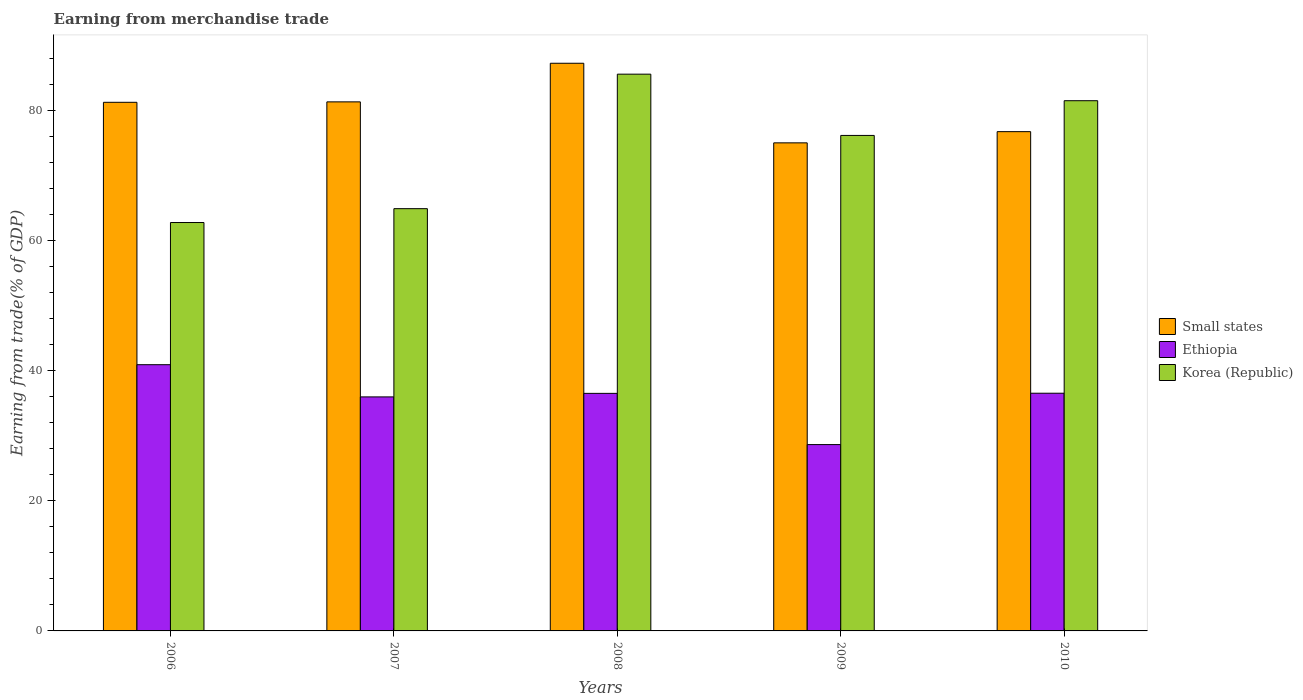How many different coloured bars are there?
Offer a terse response. 3. How many groups of bars are there?
Offer a terse response. 5. How many bars are there on the 3rd tick from the left?
Make the answer very short. 3. How many bars are there on the 5th tick from the right?
Your response must be concise. 3. What is the label of the 2nd group of bars from the left?
Make the answer very short. 2007. What is the earnings from trade in Korea (Republic) in 2008?
Ensure brevity in your answer.  85.54. Across all years, what is the maximum earnings from trade in Small states?
Your response must be concise. 87.21. Across all years, what is the minimum earnings from trade in Korea (Republic)?
Your answer should be compact. 62.74. In which year was the earnings from trade in Korea (Republic) minimum?
Keep it short and to the point. 2006. What is the total earnings from trade in Small states in the graph?
Keep it short and to the point. 401.41. What is the difference between the earnings from trade in Small states in 2006 and that in 2008?
Your response must be concise. -6. What is the difference between the earnings from trade in Korea (Republic) in 2007 and the earnings from trade in Small states in 2006?
Your answer should be compact. -16.34. What is the average earnings from trade in Ethiopia per year?
Provide a short and direct response. 35.7. In the year 2008, what is the difference between the earnings from trade in Ethiopia and earnings from trade in Small states?
Give a very brief answer. -50.72. What is the ratio of the earnings from trade in Ethiopia in 2007 to that in 2010?
Your response must be concise. 0.98. What is the difference between the highest and the second highest earnings from trade in Korea (Republic)?
Your response must be concise. 4.08. What is the difference between the highest and the lowest earnings from trade in Small states?
Give a very brief answer. 12.23. Is the sum of the earnings from trade in Small states in 2006 and 2007 greater than the maximum earnings from trade in Korea (Republic) across all years?
Offer a terse response. Yes. What does the 1st bar from the left in 2009 represents?
Offer a very short reply. Small states. What does the 2nd bar from the right in 2007 represents?
Keep it short and to the point. Ethiopia. Is it the case that in every year, the sum of the earnings from trade in Korea (Republic) and earnings from trade in Ethiopia is greater than the earnings from trade in Small states?
Your answer should be very brief. Yes. How many years are there in the graph?
Your answer should be very brief. 5. What is the difference between two consecutive major ticks on the Y-axis?
Make the answer very short. 20. Are the values on the major ticks of Y-axis written in scientific E-notation?
Provide a succinct answer. No. Does the graph contain any zero values?
Offer a terse response. No. Does the graph contain grids?
Make the answer very short. No. Where does the legend appear in the graph?
Offer a very short reply. Center right. What is the title of the graph?
Provide a succinct answer. Earning from merchandise trade. Does "Montenegro" appear as one of the legend labels in the graph?
Your answer should be very brief. No. What is the label or title of the X-axis?
Ensure brevity in your answer.  Years. What is the label or title of the Y-axis?
Offer a very short reply. Earning from trade(% of GDP). What is the Earning from trade(% of GDP) of Small states in 2006?
Offer a very short reply. 81.22. What is the Earning from trade(% of GDP) in Ethiopia in 2006?
Provide a succinct answer. 40.9. What is the Earning from trade(% of GDP) in Korea (Republic) in 2006?
Make the answer very short. 62.74. What is the Earning from trade(% of GDP) of Small states in 2007?
Provide a succinct answer. 81.28. What is the Earning from trade(% of GDP) in Ethiopia in 2007?
Offer a very short reply. 35.95. What is the Earning from trade(% of GDP) of Korea (Republic) in 2007?
Offer a very short reply. 64.87. What is the Earning from trade(% of GDP) of Small states in 2008?
Your response must be concise. 87.21. What is the Earning from trade(% of GDP) in Ethiopia in 2008?
Offer a very short reply. 36.5. What is the Earning from trade(% of GDP) of Korea (Republic) in 2008?
Keep it short and to the point. 85.54. What is the Earning from trade(% of GDP) in Small states in 2009?
Make the answer very short. 74.99. What is the Earning from trade(% of GDP) of Ethiopia in 2009?
Give a very brief answer. 28.63. What is the Earning from trade(% of GDP) in Korea (Republic) in 2009?
Give a very brief answer. 76.13. What is the Earning from trade(% of GDP) of Small states in 2010?
Offer a terse response. 76.71. What is the Earning from trade(% of GDP) in Ethiopia in 2010?
Offer a terse response. 36.52. What is the Earning from trade(% of GDP) of Korea (Republic) in 2010?
Make the answer very short. 81.46. Across all years, what is the maximum Earning from trade(% of GDP) in Small states?
Provide a short and direct response. 87.21. Across all years, what is the maximum Earning from trade(% of GDP) of Ethiopia?
Provide a short and direct response. 40.9. Across all years, what is the maximum Earning from trade(% of GDP) in Korea (Republic)?
Your answer should be very brief. 85.54. Across all years, what is the minimum Earning from trade(% of GDP) in Small states?
Your answer should be very brief. 74.99. Across all years, what is the minimum Earning from trade(% of GDP) of Ethiopia?
Offer a very short reply. 28.63. Across all years, what is the minimum Earning from trade(% of GDP) in Korea (Republic)?
Your answer should be compact. 62.74. What is the total Earning from trade(% of GDP) in Small states in the graph?
Offer a very short reply. 401.41. What is the total Earning from trade(% of GDP) in Ethiopia in the graph?
Your answer should be very brief. 178.5. What is the total Earning from trade(% of GDP) of Korea (Republic) in the graph?
Your response must be concise. 370.75. What is the difference between the Earning from trade(% of GDP) in Small states in 2006 and that in 2007?
Ensure brevity in your answer.  -0.07. What is the difference between the Earning from trade(% of GDP) in Ethiopia in 2006 and that in 2007?
Keep it short and to the point. 4.95. What is the difference between the Earning from trade(% of GDP) in Korea (Republic) in 2006 and that in 2007?
Offer a terse response. -2.13. What is the difference between the Earning from trade(% of GDP) of Small states in 2006 and that in 2008?
Your answer should be very brief. -6. What is the difference between the Earning from trade(% of GDP) in Ethiopia in 2006 and that in 2008?
Ensure brevity in your answer.  4.41. What is the difference between the Earning from trade(% of GDP) in Korea (Republic) in 2006 and that in 2008?
Your answer should be very brief. -22.79. What is the difference between the Earning from trade(% of GDP) in Small states in 2006 and that in 2009?
Ensure brevity in your answer.  6.23. What is the difference between the Earning from trade(% of GDP) of Ethiopia in 2006 and that in 2009?
Make the answer very short. 12.27. What is the difference between the Earning from trade(% of GDP) in Korea (Republic) in 2006 and that in 2009?
Your answer should be very brief. -13.38. What is the difference between the Earning from trade(% of GDP) of Small states in 2006 and that in 2010?
Ensure brevity in your answer.  4.51. What is the difference between the Earning from trade(% of GDP) in Ethiopia in 2006 and that in 2010?
Offer a very short reply. 4.38. What is the difference between the Earning from trade(% of GDP) in Korea (Republic) in 2006 and that in 2010?
Provide a short and direct response. -18.72. What is the difference between the Earning from trade(% of GDP) in Small states in 2007 and that in 2008?
Provide a short and direct response. -5.93. What is the difference between the Earning from trade(% of GDP) of Ethiopia in 2007 and that in 2008?
Provide a short and direct response. -0.54. What is the difference between the Earning from trade(% of GDP) of Korea (Republic) in 2007 and that in 2008?
Offer a very short reply. -20.66. What is the difference between the Earning from trade(% of GDP) of Small states in 2007 and that in 2009?
Provide a succinct answer. 6.3. What is the difference between the Earning from trade(% of GDP) of Ethiopia in 2007 and that in 2009?
Provide a short and direct response. 7.33. What is the difference between the Earning from trade(% of GDP) of Korea (Republic) in 2007 and that in 2009?
Your answer should be very brief. -11.25. What is the difference between the Earning from trade(% of GDP) of Small states in 2007 and that in 2010?
Make the answer very short. 4.58. What is the difference between the Earning from trade(% of GDP) of Ethiopia in 2007 and that in 2010?
Make the answer very short. -0.56. What is the difference between the Earning from trade(% of GDP) in Korea (Republic) in 2007 and that in 2010?
Offer a very short reply. -16.59. What is the difference between the Earning from trade(% of GDP) in Small states in 2008 and that in 2009?
Your answer should be compact. 12.23. What is the difference between the Earning from trade(% of GDP) in Ethiopia in 2008 and that in 2009?
Give a very brief answer. 7.87. What is the difference between the Earning from trade(% of GDP) in Korea (Republic) in 2008 and that in 2009?
Your answer should be very brief. 9.41. What is the difference between the Earning from trade(% of GDP) in Small states in 2008 and that in 2010?
Provide a short and direct response. 10.51. What is the difference between the Earning from trade(% of GDP) of Ethiopia in 2008 and that in 2010?
Keep it short and to the point. -0.02. What is the difference between the Earning from trade(% of GDP) in Korea (Republic) in 2008 and that in 2010?
Provide a short and direct response. 4.08. What is the difference between the Earning from trade(% of GDP) of Small states in 2009 and that in 2010?
Provide a succinct answer. -1.72. What is the difference between the Earning from trade(% of GDP) in Ethiopia in 2009 and that in 2010?
Offer a very short reply. -7.89. What is the difference between the Earning from trade(% of GDP) in Korea (Republic) in 2009 and that in 2010?
Offer a terse response. -5.33. What is the difference between the Earning from trade(% of GDP) in Small states in 2006 and the Earning from trade(% of GDP) in Ethiopia in 2007?
Ensure brevity in your answer.  45.26. What is the difference between the Earning from trade(% of GDP) of Small states in 2006 and the Earning from trade(% of GDP) of Korea (Republic) in 2007?
Offer a terse response. 16.34. What is the difference between the Earning from trade(% of GDP) in Ethiopia in 2006 and the Earning from trade(% of GDP) in Korea (Republic) in 2007?
Your answer should be very brief. -23.97. What is the difference between the Earning from trade(% of GDP) in Small states in 2006 and the Earning from trade(% of GDP) in Ethiopia in 2008?
Your answer should be compact. 44.72. What is the difference between the Earning from trade(% of GDP) in Small states in 2006 and the Earning from trade(% of GDP) in Korea (Republic) in 2008?
Offer a very short reply. -4.32. What is the difference between the Earning from trade(% of GDP) of Ethiopia in 2006 and the Earning from trade(% of GDP) of Korea (Republic) in 2008?
Give a very brief answer. -44.64. What is the difference between the Earning from trade(% of GDP) of Small states in 2006 and the Earning from trade(% of GDP) of Ethiopia in 2009?
Provide a succinct answer. 52.59. What is the difference between the Earning from trade(% of GDP) of Small states in 2006 and the Earning from trade(% of GDP) of Korea (Republic) in 2009?
Offer a terse response. 5.09. What is the difference between the Earning from trade(% of GDP) in Ethiopia in 2006 and the Earning from trade(% of GDP) in Korea (Republic) in 2009?
Make the answer very short. -35.22. What is the difference between the Earning from trade(% of GDP) in Small states in 2006 and the Earning from trade(% of GDP) in Ethiopia in 2010?
Provide a succinct answer. 44.7. What is the difference between the Earning from trade(% of GDP) in Small states in 2006 and the Earning from trade(% of GDP) in Korea (Republic) in 2010?
Provide a short and direct response. -0.25. What is the difference between the Earning from trade(% of GDP) of Ethiopia in 2006 and the Earning from trade(% of GDP) of Korea (Republic) in 2010?
Make the answer very short. -40.56. What is the difference between the Earning from trade(% of GDP) in Small states in 2007 and the Earning from trade(% of GDP) in Ethiopia in 2008?
Your answer should be very brief. 44.79. What is the difference between the Earning from trade(% of GDP) of Small states in 2007 and the Earning from trade(% of GDP) of Korea (Republic) in 2008?
Offer a very short reply. -4.26. What is the difference between the Earning from trade(% of GDP) of Ethiopia in 2007 and the Earning from trade(% of GDP) of Korea (Republic) in 2008?
Provide a short and direct response. -49.58. What is the difference between the Earning from trade(% of GDP) of Small states in 2007 and the Earning from trade(% of GDP) of Ethiopia in 2009?
Provide a succinct answer. 52.65. What is the difference between the Earning from trade(% of GDP) of Small states in 2007 and the Earning from trade(% of GDP) of Korea (Republic) in 2009?
Provide a short and direct response. 5.16. What is the difference between the Earning from trade(% of GDP) in Ethiopia in 2007 and the Earning from trade(% of GDP) in Korea (Republic) in 2009?
Your answer should be compact. -40.17. What is the difference between the Earning from trade(% of GDP) of Small states in 2007 and the Earning from trade(% of GDP) of Ethiopia in 2010?
Offer a very short reply. 44.76. What is the difference between the Earning from trade(% of GDP) in Small states in 2007 and the Earning from trade(% of GDP) in Korea (Republic) in 2010?
Offer a very short reply. -0.18. What is the difference between the Earning from trade(% of GDP) in Ethiopia in 2007 and the Earning from trade(% of GDP) in Korea (Republic) in 2010?
Your response must be concise. -45.51. What is the difference between the Earning from trade(% of GDP) in Small states in 2008 and the Earning from trade(% of GDP) in Ethiopia in 2009?
Ensure brevity in your answer.  58.59. What is the difference between the Earning from trade(% of GDP) in Small states in 2008 and the Earning from trade(% of GDP) in Korea (Republic) in 2009?
Your response must be concise. 11.09. What is the difference between the Earning from trade(% of GDP) of Ethiopia in 2008 and the Earning from trade(% of GDP) of Korea (Republic) in 2009?
Provide a succinct answer. -39.63. What is the difference between the Earning from trade(% of GDP) in Small states in 2008 and the Earning from trade(% of GDP) in Ethiopia in 2010?
Give a very brief answer. 50.7. What is the difference between the Earning from trade(% of GDP) in Small states in 2008 and the Earning from trade(% of GDP) in Korea (Republic) in 2010?
Your answer should be very brief. 5.75. What is the difference between the Earning from trade(% of GDP) of Ethiopia in 2008 and the Earning from trade(% of GDP) of Korea (Republic) in 2010?
Offer a terse response. -44.97. What is the difference between the Earning from trade(% of GDP) of Small states in 2009 and the Earning from trade(% of GDP) of Ethiopia in 2010?
Your response must be concise. 38.47. What is the difference between the Earning from trade(% of GDP) in Small states in 2009 and the Earning from trade(% of GDP) in Korea (Republic) in 2010?
Your answer should be very brief. -6.48. What is the difference between the Earning from trade(% of GDP) in Ethiopia in 2009 and the Earning from trade(% of GDP) in Korea (Republic) in 2010?
Offer a terse response. -52.83. What is the average Earning from trade(% of GDP) in Small states per year?
Make the answer very short. 80.28. What is the average Earning from trade(% of GDP) of Ethiopia per year?
Your answer should be very brief. 35.7. What is the average Earning from trade(% of GDP) of Korea (Republic) per year?
Your answer should be very brief. 74.15. In the year 2006, what is the difference between the Earning from trade(% of GDP) in Small states and Earning from trade(% of GDP) in Ethiopia?
Your answer should be compact. 40.31. In the year 2006, what is the difference between the Earning from trade(% of GDP) of Small states and Earning from trade(% of GDP) of Korea (Republic)?
Provide a succinct answer. 18.47. In the year 2006, what is the difference between the Earning from trade(% of GDP) in Ethiopia and Earning from trade(% of GDP) in Korea (Republic)?
Offer a very short reply. -21.84. In the year 2007, what is the difference between the Earning from trade(% of GDP) of Small states and Earning from trade(% of GDP) of Ethiopia?
Provide a short and direct response. 45.33. In the year 2007, what is the difference between the Earning from trade(% of GDP) in Small states and Earning from trade(% of GDP) in Korea (Republic)?
Your answer should be compact. 16.41. In the year 2007, what is the difference between the Earning from trade(% of GDP) in Ethiopia and Earning from trade(% of GDP) in Korea (Republic)?
Offer a very short reply. -28.92. In the year 2008, what is the difference between the Earning from trade(% of GDP) of Small states and Earning from trade(% of GDP) of Ethiopia?
Your response must be concise. 50.72. In the year 2008, what is the difference between the Earning from trade(% of GDP) in Small states and Earning from trade(% of GDP) in Korea (Republic)?
Your response must be concise. 1.68. In the year 2008, what is the difference between the Earning from trade(% of GDP) in Ethiopia and Earning from trade(% of GDP) in Korea (Republic)?
Offer a terse response. -49.04. In the year 2009, what is the difference between the Earning from trade(% of GDP) of Small states and Earning from trade(% of GDP) of Ethiopia?
Ensure brevity in your answer.  46.36. In the year 2009, what is the difference between the Earning from trade(% of GDP) in Small states and Earning from trade(% of GDP) in Korea (Republic)?
Give a very brief answer. -1.14. In the year 2009, what is the difference between the Earning from trade(% of GDP) of Ethiopia and Earning from trade(% of GDP) of Korea (Republic)?
Ensure brevity in your answer.  -47.5. In the year 2010, what is the difference between the Earning from trade(% of GDP) of Small states and Earning from trade(% of GDP) of Ethiopia?
Your answer should be compact. 40.19. In the year 2010, what is the difference between the Earning from trade(% of GDP) in Small states and Earning from trade(% of GDP) in Korea (Republic)?
Provide a short and direct response. -4.75. In the year 2010, what is the difference between the Earning from trade(% of GDP) of Ethiopia and Earning from trade(% of GDP) of Korea (Republic)?
Ensure brevity in your answer.  -44.94. What is the ratio of the Earning from trade(% of GDP) in Ethiopia in 2006 to that in 2007?
Your answer should be very brief. 1.14. What is the ratio of the Earning from trade(% of GDP) in Korea (Republic) in 2006 to that in 2007?
Provide a succinct answer. 0.97. What is the ratio of the Earning from trade(% of GDP) in Small states in 2006 to that in 2008?
Provide a short and direct response. 0.93. What is the ratio of the Earning from trade(% of GDP) of Ethiopia in 2006 to that in 2008?
Offer a terse response. 1.12. What is the ratio of the Earning from trade(% of GDP) of Korea (Republic) in 2006 to that in 2008?
Your answer should be compact. 0.73. What is the ratio of the Earning from trade(% of GDP) in Small states in 2006 to that in 2009?
Offer a very short reply. 1.08. What is the ratio of the Earning from trade(% of GDP) of Ethiopia in 2006 to that in 2009?
Your answer should be very brief. 1.43. What is the ratio of the Earning from trade(% of GDP) of Korea (Republic) in 2006 to that in 2009?
Give a very brief answer. 0.82. What is the ratio of the Earning from trade(% of GDP) in Small states in 2006 to that in 2010?
Offer a very short reply. 1.06. What is the ratio of the Earning from trade(% of GDP) in Ethiopia in 2006 to that in 2010?
Your response must be concise. 1.12. What is the ratio of the Earning from trade(% of GDP) of Korea (Republic) in 2006 to that in 2010?
Offer a terse response. 0.77. What is the ratio of the Earning from trade(% of GDP) of Small states in 2007 to that in 2008?
Give a very brief answer. 0.93. What is the ratio of the Earning from trade(% of GDP) of Ethiopia in 2007 to that in 2008?
Your answer should be very brief. 0.99. What is the ratio of the Earning from trade(% of GDP) of Korea (Republic) in 2007 to that in 2008?
Offer a very short reply. 0.76. What is the ratio of the Earning from trade(% of GDP) of Small states in 2007 to that in 2009?
Offer a terse response. 1.08. What is the ratio of the Earning from trade(% of GDP) of Ethiopia in 2007 to that in 2009?
Your answer should be very brief. 1.26. What is the ratio of the Earning from trade(% of GDP) of Korea (Republic) in 2007 to that in 2009?
Make the answer very short. 0.85. What is the ratio of the Earning from trade(% of GDP) of Small states in 2007 to that in 2010?
Give a very brief answer. 1.06. What is the ratio of the Earning from trade(% of GDP) in Ethiopia in 2007 to that in 2010?
Provide a short and direct response. 0.98. What is the ratio of the Earning from trade(% of GDP) in Korea (Republic) in 2007 to that in 2010?
Make the answer very short. 0.8. What is the ratio of the Earning from trade(% of GDP) in Small states in 2008 to that in 2009?
Make the answer very short. 1.16. What is the ratio of the Earning from trade(% of GDP) in Ethiopia in 2008 to that in 2009?
Keep it short and to the point. 1.27. What is the ratio of the Earning from trade(% of GDP) in Korea (Republic) in 2008 to that in 2009?
Provide a short and direct response. 1.12. What is the ratio of the Earning from trade(% of GDP) of Small states in 2008 to that in 2010?
Keep it short and to the point. 1.14. What is the ratio of the Earning from trade(% of GDP) in Ethiopia in 2008 to that in 2010?
Your response must be concise. 1. What is the ratio of the Earning from trade(% of GDP) of Small states in 2009 to that in 2010?
Provide a short and direct response. 0.98. What is the ratio of the Earning from trade(% of GDP) of Ethiopia in 2009 to that in 2010?
Ensure brevity in your answer.  0.78. What is the ratio of the Earning from trade(% of GDP) of Korea (Republic) in 2009 to that in 2010?
Your response must be concise. 0.93. What is the difference between the highest and the second highest Earning from trade(% of GDP) in Small states?
Make the answer very short. 5.93. What is the difference between the highest and the second highest Earning from trade(% of GDP) of Ethiopia?
Make the answer very short. 4.38. What is the difference between the highest and the second highest Earning from trade(% of GDP) in Korea (Republic)?
Give a very brief answer. 4.08. What is the difference between the highest and the lowest Earning from trade(% of GDP) in Small states?
Give a very brief answer. 12.23. What is the difference between the highest and the lowest Earning from trade(% of GDP) of Ethiopia?
Make the answer very short. 12.27. What is the difference between the highest and the lowest Earning from trade(% of GDP) of Korea (Republic)?
Provide a short and direct response. 22.79. 